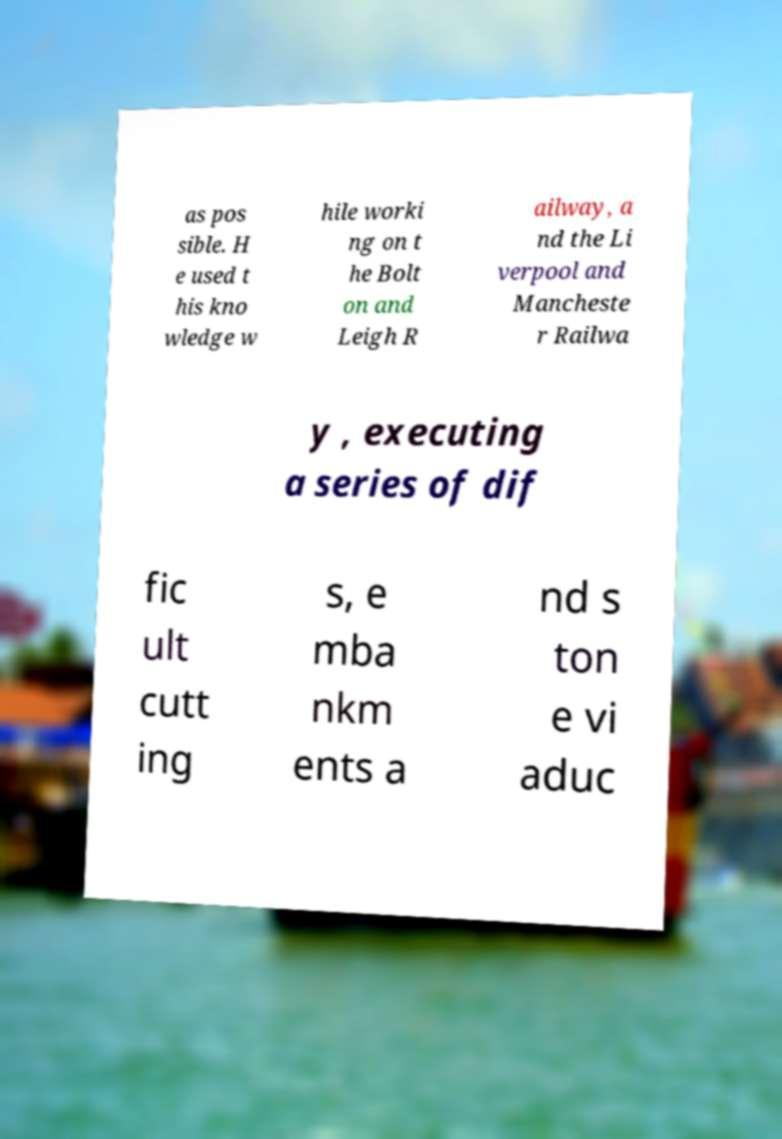Could you assist in decoding the text presented in this image and type it out clearly? as pos sible. H e used t his kno wledge w hile worki ng on t he Bolt on and Leigh R ailway, a nd the Li verpool and Mancheste r Railwa y , executing a series of dif fic ult cutt ing s, e mba nkm ents a nd s ton e vi aduc 